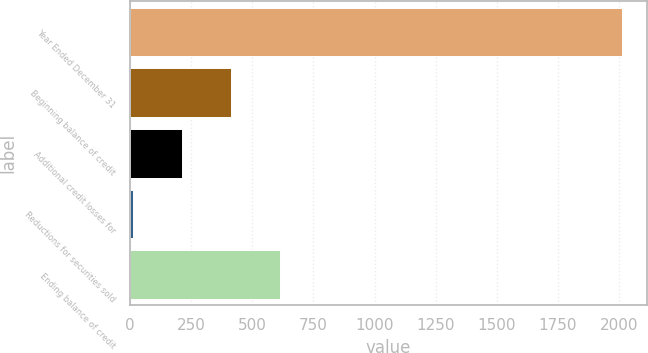Convert chart. <chart><loc_0><loc_0><loc_500><loc_500><bar_chart><fcel>Year Ended December 31<fcel>Beginning balance of credit<fcel>Additional credit losses for<fcel>Reductions for securities sold<fcel>Ending balance of credit<nl><fcel>2012<fcel>413.6<fcel>213.8<fcel>14<fcel>613.4<nl></chart> 